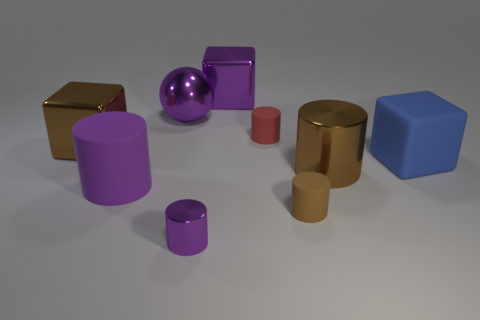Subtract all brown blocks. How many purple cylinders are left? 2 Subtract all purple cylinders. How many cylinders are left? 3 Subtract all brown metallic cylinders. How many cylinders are left? 4 Add 1 large gray rubber objects. How many objects exist? 10 Subtract all red cylinders. Subtract all purple balls. How many cylinders are left? 4 Subtract all blocks. How many objects are left? 6 Subtract all cyan cylinders. Subtract all large brown things. How many objects are left? 7 Add 6 big blue things. How many big blue things are left? 7 Add 8 green rubber objects. How many green rubber objects exist? 8 Subtract 0 gray cylinders. How many objects are left? 9 